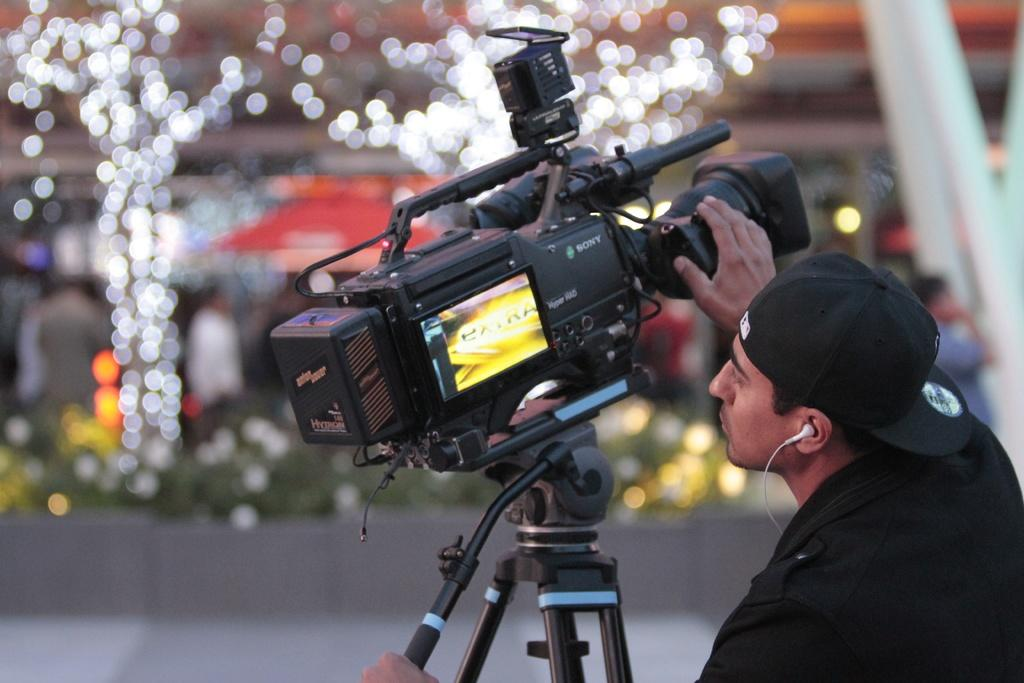What is the main subject of the image? There is a person in the image. What is the person wearing? The person is wearing a black shirt and a cap. What is the person holding in the image? The person is holding a camera. What other camera-related object can be seen in the image? There is a camera stand in the image. What type of horn can be heard playing in the background of the image? There is no horn or sound present in the image; it is a still photograph. Can you recite a verse from the poem that is visible in the image? There is no poem or verse present in the image; it is a photograph of a person holding a camera. 